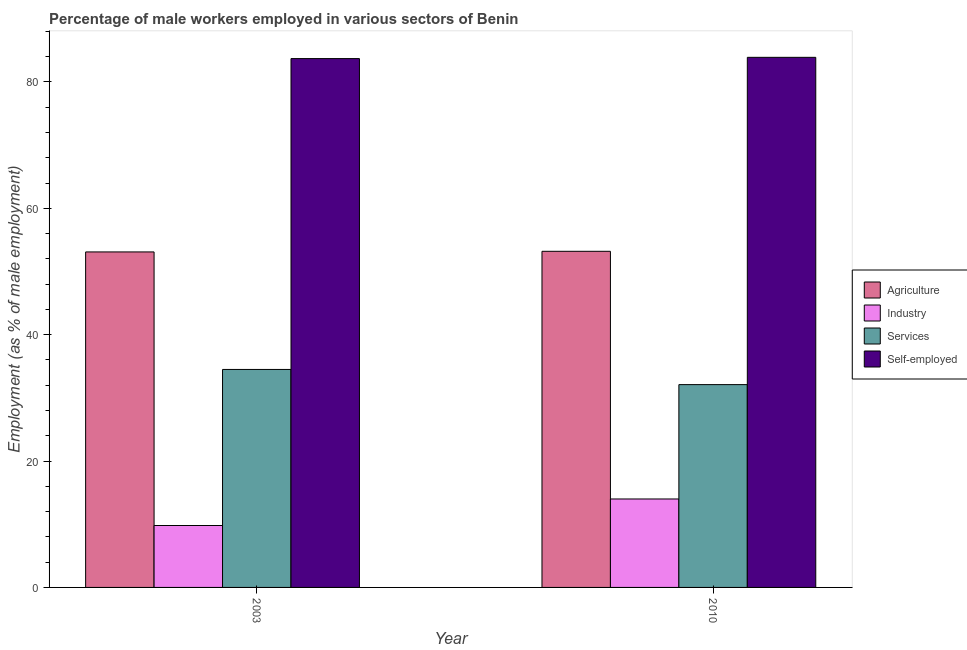How many groups of bars are there?
Ensure brevity in your answer.  2. Are the number of bars per tick equal to the number of legend labels?
Provide a short and direct response. Yes. How many bars are there on the 2nd tick from the left?
Your response must be concise. 4. In how many cases, is the number of bars for a given year not equal to the number of legend labels?
Offer a terse response. 0. What is the percentage of male workers in agriculture in 2010?
Your answer should be very brief. 53.2. Across all years, what is the maximum percentage of male workers in agriculture?
Make the answer very short. 53.2. Across all years, what is the minimum percentage of self employed male workers?
Offer a terse response. 83.7. What is the total percentage of male workers in agriculture in the graph?
Your answer should be very brief. 106.3. What is the difference between the percentage of male workers in industry in 2003 and that in 2010?
Keep it short and to the point. -4.2. What is the difference between the percentage of male workers in services in 2010 and the percentage of male workers in agriculture in 2003?
Provide a short and direct response. -2.4. What is the average percentage of male workers in services per year?
Provide a short and direct response. 33.3. In the year 2003, what is the difference between the percentage of male workers in services and percentage of male workers in industry?
Offer a very short reply. 0. What is the ratio of the percentage of male workers in services in 2003 to that in 2010?
Ensure brevity in your answer.  1.07. Is the percentage of self employed male workers in 2003 less than that in 2010?
Give a very brief answer. Yes. In how many years, is the percentage of self employed male workers greater than the average percentage of self employed male workers taken over all years?
Your answer should be compact. 1. What does the 3rd bar from the left in 2003 represents?
Offer a very short reply. Services. What does the 1st bar from the right in 2010 represents?
Your response must be concise. Self-employed. Is it the case that in every year, the sum of the percentage of male workers in agriculture and percentage of male workers in industry is greater than the percentage of male workers in services?
Make the answer very short. Yes. How many bars are there?
Your answer should be very brief. 8. What is the difference between two consecutive major ticks on the Y-axis?
Give a very brief answer. 20. Are the values on the major ticks of Y-axis written in scientific E-notation?
Keep it short and to the point. No. Does the graph contain grids?
Offer a very short reply. No. Where does the legend appear in the graph?
Your answer should be very brief. Center right. How many legend labels are there?
Your answer should be very brief. 4. What is the title of the graph?
Offer a very short reply. Percentage of male workers employed in various sectors of Benin. What is the label or title of the X-axis?
Your answer should be compact. Year. What is the label or title of the Y-axis?
Make the answer very short. Employment (as % of male employment). What is the Employment (as % of male employment) of Agriculture in 2003?
Ensure brevity in your answer.  53.1. What is the Employment (as % of male employment) of Industry in 2003?
Offer a very short reply. 9.8. What is the Employment (as % of male employment) in Services in 2003?
Make the answer very short. 34.5. What is the Employment (as % of male employment) in Self-employed in 2003?
Ensure brevity in your answer.  83.7. What is the Employment (as % of male employment) in Agriculture in 2010?
Give a very brief answer. 53.2. What is the Employment (as % of male employment) of Services in 2010?
Give a very brief answer. 32.1. What is the Employment (as % of male employment) in Self-employed in 2010?
Give a very brief answer. 83.9. Across all years, what is the maximum Employment (as % of male employment) of Agriculture?
Provide a short and direct response. 53.2. Across all years, what is the maximum Employment (as % of male employment) in Services?
Your response must be concise. 34.5. Across all years, what is the maximum Employment (as % of male employment) of Self-employed?
Ensure brevity in your answer.  83.9. Across all years, what is the minimum Employment (as % of male employment) in Agriculture?
Make the answer very short. 53.1. Across all years, what is the minimum Employment (as % of male employment) of Industry?
Give a very brief answer. 9.8. Across all years, what is the minimum Employment (as % of male employment) of Services?
Your answer should be very brief. 32.1. Across all years, what is the minimum Employment (as % of male employment) in Self-employed?
Offer a very short reply. 83.7. What is the total Employment (as % of male employment) of Agriculture in the graph?
Ensure brevity in your answer.  106.3. What is the total Employment (as % of male employment) of Industry in the graph?
Ensure brevity in your answer.  23.8. What is the total Employment (as % of male employment) in Services in the graph?
Provide a short and direct response. 66.6. What is the total Employment (as % of male employment) in Self-employed in the graph?
Give a very brief answer. 167.6. What is the difference between the Employment (as % of male employment) in Agriculture in 2003 and that in 2010?
Provide a short and direct response. -0.1. What is the difference between the Employment (as % of male employment) of Industry in 2003 and that in 2010?
Offer a very short reply. -4.2. What is the difference between the Employment (as % of male employment) of Services in 2003 and that in 2010?
Your answer should be very brief. 2.4. What is the difference between the Employment (as % of male employment) in Agriculture in 2003 and the Employment (as % of male employment) in Industry in 2010?
Make the answer very short. 39.1. What is the difference between the Employment (as % of male employment) of Agriculture in 2003 and the Employment (as % of male employment) of Services in 2010?
Your answer should be very brief. 21. What is the difference between the Employment (as % of male employment) of Agriculture in 2003 and the Employment (as % of male employment) of Self-employed in 2010?
Make the answer very short. -30.8. What is the difference between the Employment (as % of male employment) of Industry in 2003 and the Employment (as % of male employment) of Services in 2010?
Make the answer very short. -22.3. What is the difference between the Employment (as % of male employment) of Industry in 2003 and the Employment (as % of male employment) of Self-employed in 2010?
Make the answer very short. -74.1. What is the difference between the Employment (as % of male employment) in Services in 2003 and the Employment (as % of male employment) in Self-employed in 2010?
Keep it short and to the point. -49.4. What is the average Employment (as % of male employment) of Agriculture per year?
Offer a very short reply. 53.15. What is the average Employment (as % of male employment) of Services per year?
Make the answer very short. 33.3. What is the average Employment (as % of male employment) in Self-employed per year?
Offer a very short reply. 83.8. In the year 2003, what is the difference between the Employment (as % of male employment) in Agriculture and Employment (as % of male employment) in Industry?
Ensure brevity in your answer.  43.3. In the year 2003, what is the difference between the Employment (as % of male employment) in Agriculture and Employment (as % of male employment) in Self-employed?
Offer a very short reply. -30.6. In the year 2003, what is the difference between the Employment (as % of male employment) in Industry and Employment (as % of male employment) in Services?
Your answer should be compact. -24.7. In the year 2003, what is the difference between the Employment (as % of male employment) in Industry and Employment (as % of male employment) in Self-employed?
Provide a short and direct response. -73.9. In the year 2003, what is the difference between the Employment (as % of male employment) of Services and Employment (as % of male employment) of Self-employed?
Keep it short and to the point. -49.2. In the year 2010, what is the difference between the Employment (as % of male employment) of Agriculture and Employment (as % of male employment) of Industry?
Give a very brief answer. 39.2. In the year 2010, what is the difference between the Employment (as % of male employment) of Agriculture and Employment (as % of male employment) of Services?
Your response must be concise. 21.1. In the year 2010, what is the difference between the Employment (as % of male employment) of Agriculture and Employment (as % of male employment) of Self-employed?
Your response must be concise. -30.7. In the year 2010, what is the difference between the Employment (as % of male employment) of Industry and Employment (as % of male employment) of Services?
Your response must be concise. -18.1. In the year 2010, what is the difference between the Employment (as % of male employment) in Industry and Employment (as % of male employment) in Self-employed?
Your response must be concise. -69.9. In the year 2010, what is the difference between the Employment (as % of male employment) in Services and Employment (as % of male employment) in Self-employed?
Offer a very short reply. -51.8. What is the ratio of the Employment (as % of male employment) in Services in 2003 to that in 2010?
Keep it short and to the point. 1.07. What is the difference between the highest and the second highest Employment (as % of male employment) in Agriculture?
Offer a very short reply. 0.1. What is the difference between the highest and the second highest Employment (as % of male employment) in Services?
Give a very brief answer. 2.4. What is the difference between the highest and the lowest Employment (as % of male employment) of Industry?
Your answer should be compact. 4.2. What is the difference between the highest and the lowest Employment (as % of male employment) in Services?
Give a very brief answer. 2.4. What is the difference between the highest and the lowest Employment (as % of male employment) of Self-employed?
Your answer should be compact. 0.2. 